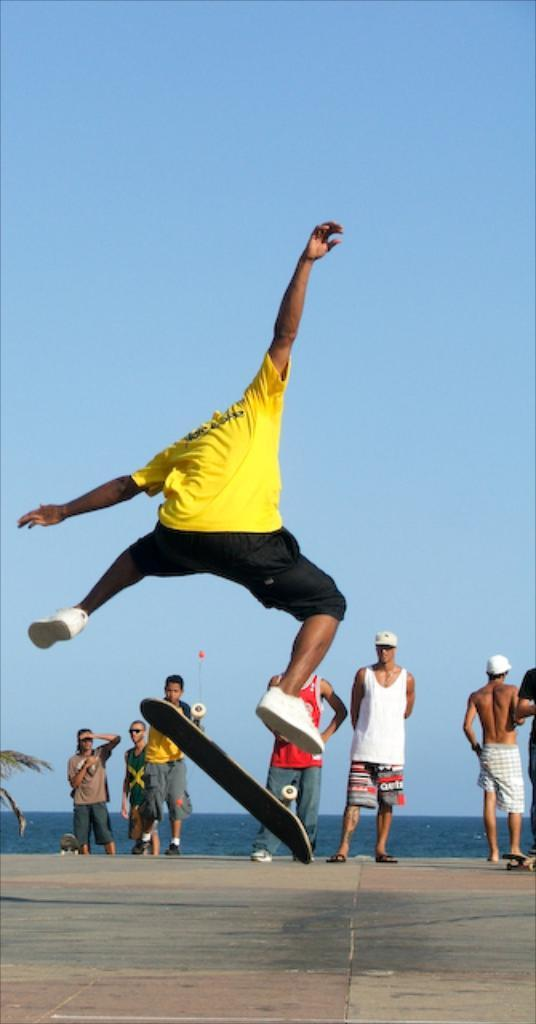What is the person in the image doing? The person in the image is jumping with a skateboard. Are there any other people in the image? Yes, there is a group of people standing in the image. What can be seen in the background of the image? The sky is visible in the background of the image. What natural element is present in the image? There is a tree in the image. What else can be seen in the image besides the people and the tree? There is water visible in the image. What type of glove is the person wearing while jumping with the skateboard? There is no glove visible in the image; the person is not wearing any gloves. 